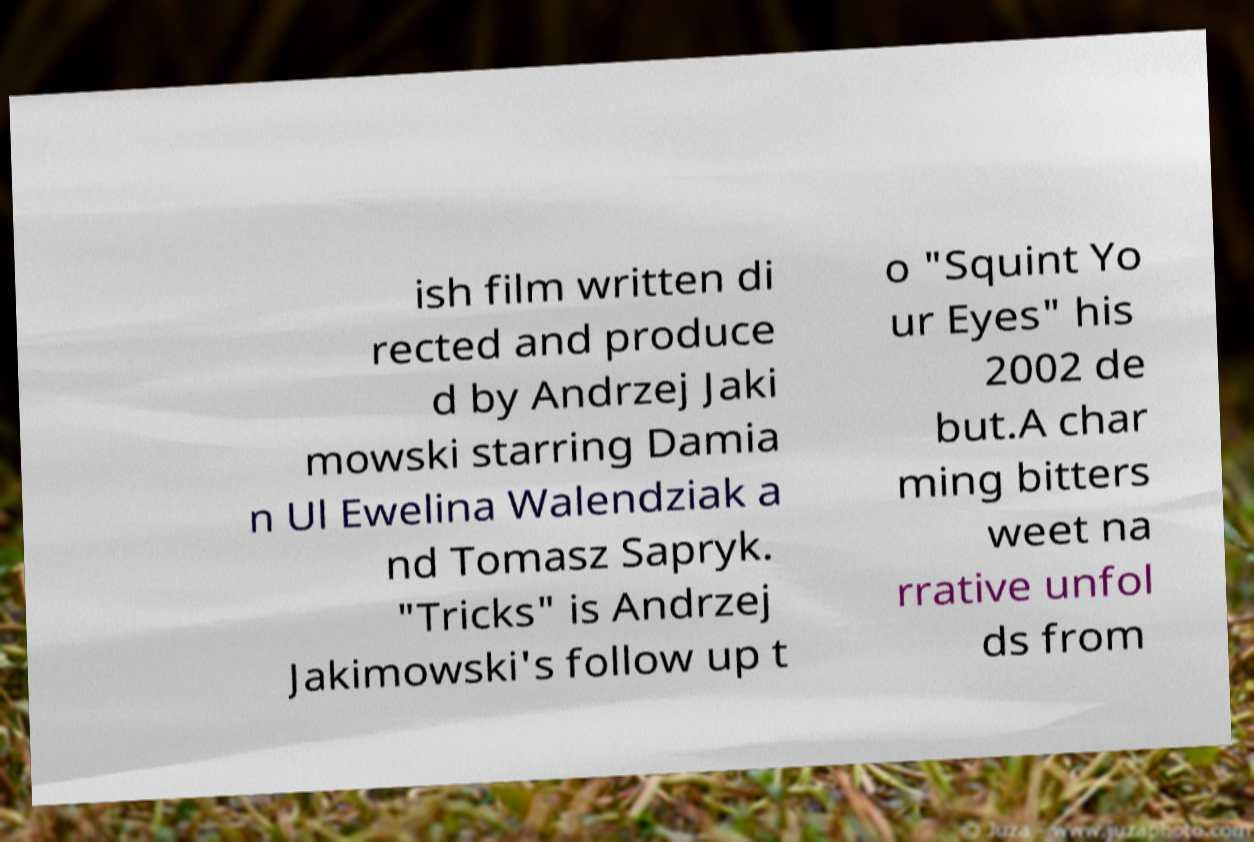Can you accurately transcribe the text from the provided image for me? ish film written di rected and produce d by Andrzej Jaki mowski starring Damia n Ul Ewelina Walendziak a nd Tomasz Sapryk. "Tricks" is Andrzej Jakimowski's follow up t o "Squint Yo ur Eyes" his 2002 de but.A char ming bitters weet na rrative unfol ds from 